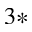<formula> <loc_0><loc_0><loc_500><loc_500>^ { 3 * }</formula> 